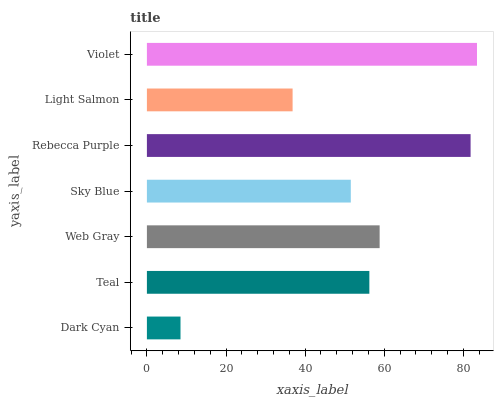Is Dark Cyan the minimum?
Answer yes or no. Yes. Is Violet the maximum?
Answer yes or no. Yes. Is Teal the minimum?
Answer yes or no. No. Is Teal the maximum?
Answer yes or no. No. Is Teal greater than Dark Cyan?
Answer yes or no. Yes. Is Dark Cyan less than Teal?
Answer yes or no. Yes. Is Dark Cyan greater than Teal?
Answer yes or no. No. Is Teal less than Dark Cyan?
Answer yes or no. No. Is Teal the high median?
Answer yes or no. Yes. Is Teal the low median?
Answer yes or no. Yes. Is Web Gray the high median?
Answer yes or no. No. Is Rebecca Purple the low median?
Answer yes or no. No. 